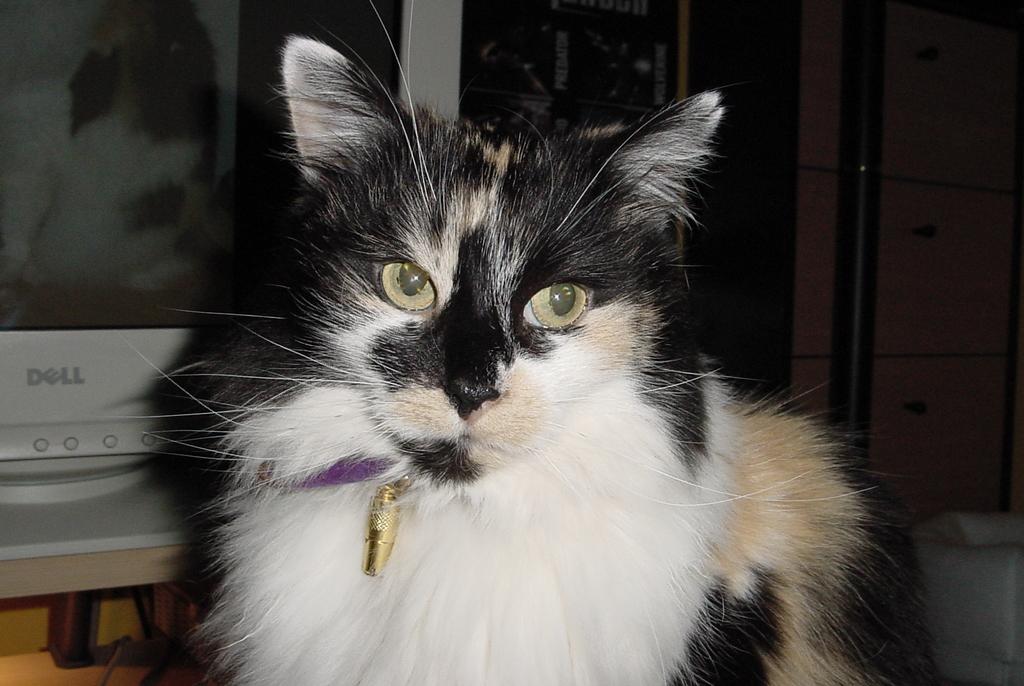What brand is the computer?
Keep it short and to the point. Dell. What is the first letter displayed on the monitor?
Keep it short and to the point. D. 